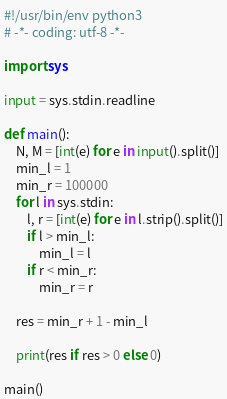<code> <loc_0><loc_0><loc_500><loc_500><_Python_>#!/usr/bin/env python3
# -*- coding: utf-8 -*-

import sys

input = sys.stdin.readline

def main():
    N, M = [int(e) for e in input().split()]
    min_l = 1
    min_r = 100000
    for l in sys.stdin:
        l, r = [int(e) for e in l.strip().split()]
        if l > min_l:
            min_l = l
        if r < min_r:
            min_r = r

    res = min_r + 1 - min_l

    print(res if res > 0 else 0)

main()
</code> 